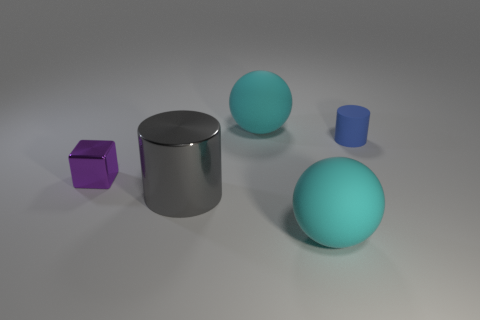What number of tiny blue rubber objects are there?
Offer a terse response. 1. What shape is the metal thing that is in front of the purple block?
Provide a short and direct response. Cylinder. The matte sphere that is to the left of the thing in front of the cylinder that is in front of the purple object is what color?
Keep it short and to the point. Cyan. There is another thing that is made of the same material as the gray object; what is its shape?
Make the answer very short. Cube. Are there fewer balls than rubber objects?
Your answer should be compact. Yes. Are the big cylinder and the tiny purple cube made of the same material?
Offer a terse response. Yes. What number of other objects are there of the same color as the small rubber cylinder?
Provide a succinct answer. 0. Is the number of purple things greater than the number of tiny cyan metal cylinders?
Your response must be concise. Yes. Is the size of the purple thing the same as the cylinder behind the shiny block?
Provide a succinct answer. Yes. The tiny object left of the small rubber cylinder is what color?
Your response must be concise. Purple. 